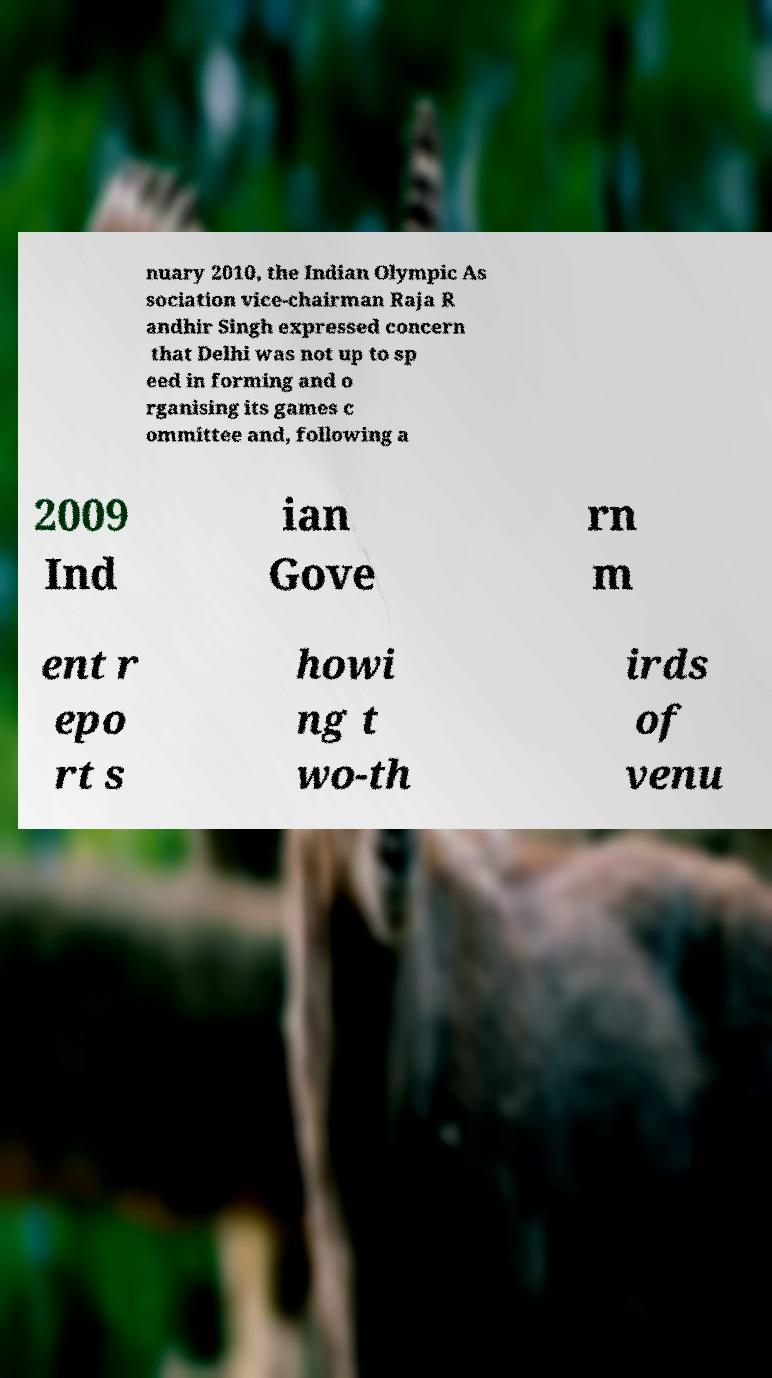I need the written content from this picture converted into text. Can you do that? nuary 2010, the Indian Olympic As sociation vice-chairman Raja R andhir Singh expressed concern that Delhi was not up to sp eed in forming and o rganising its games c ommittee and, following a 2009 Ind ian Gove rn m ent r epo rt s howi ng t wo-th irds of venu 